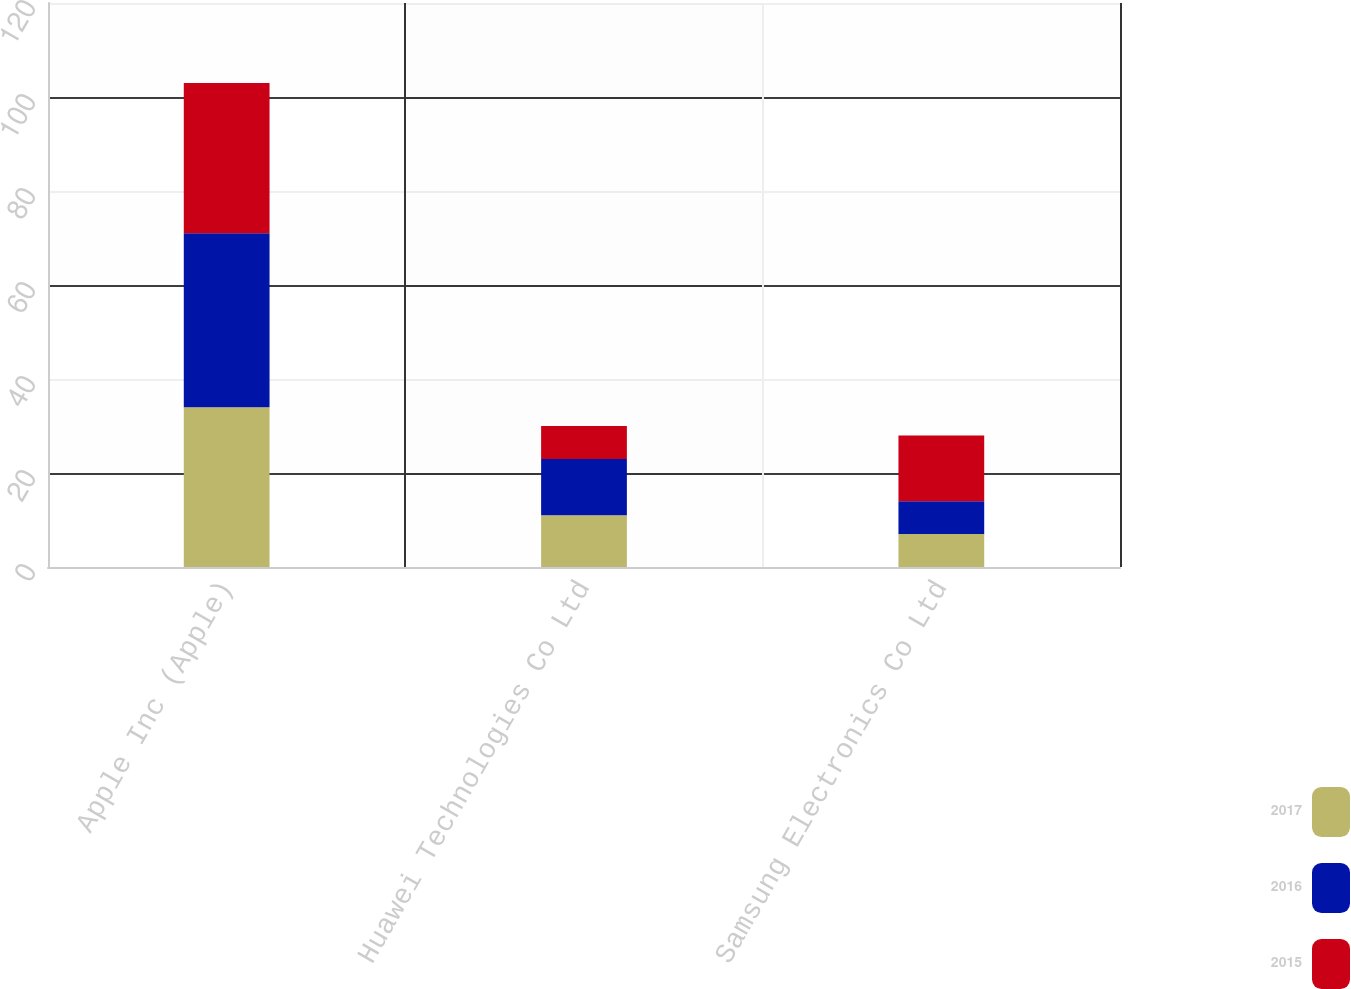Convert chart. <chart><loc_0><loc_0><loc_500><loc_500><stacked_bar_chart><ecel><fcel>Apple Inc (Apple)<fcel>Huawei Technologies Co Ltd<fcel>Samsung Electronics Co Ltd<nl><fcel>2017<fcel>34<fcel>11<fcel>7<nl><fcel>2016<fcel>37<fcel>12<fcel>7<nl><fcel>2015<fcel>32<fcel>7<fcel>14<nl></chart> 